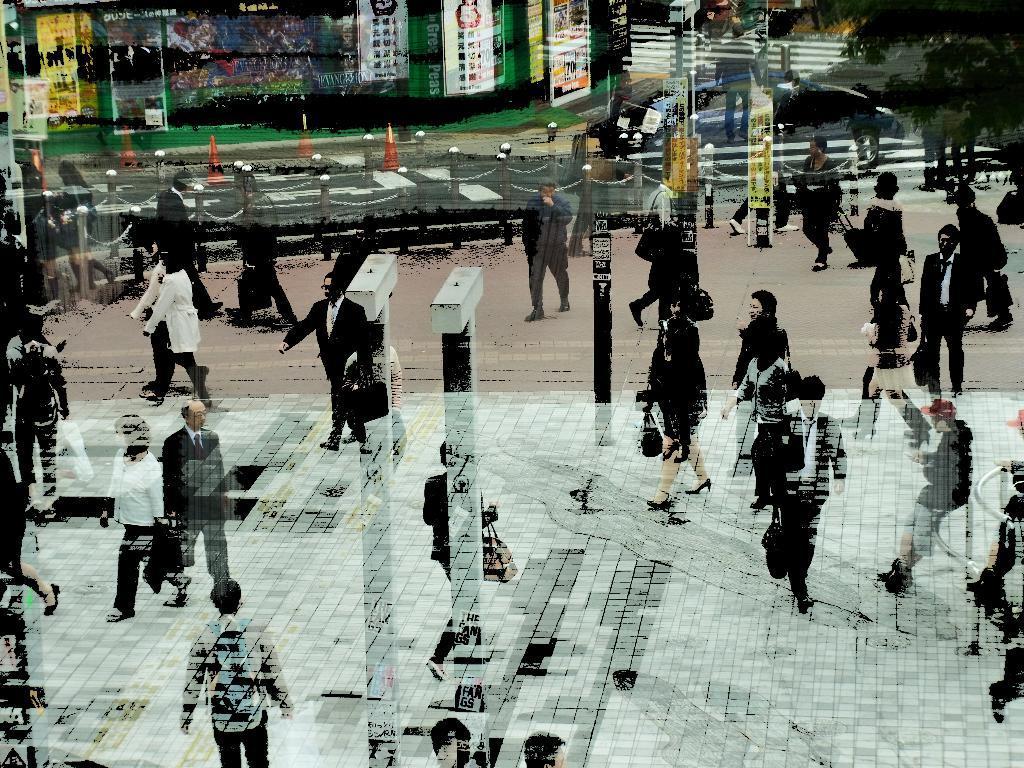Could you give a brief overview of what you see in this image? It is an edited picture. In this image, we can see a group of people, poles, road, chain, traffic cone, banners, tree. 